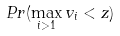Convert formula to latex. <formula><loc_0><loc_0><loc_500><loc_500>P r ( \max _ { i > 1 } v _ { i } < z )</formula> 